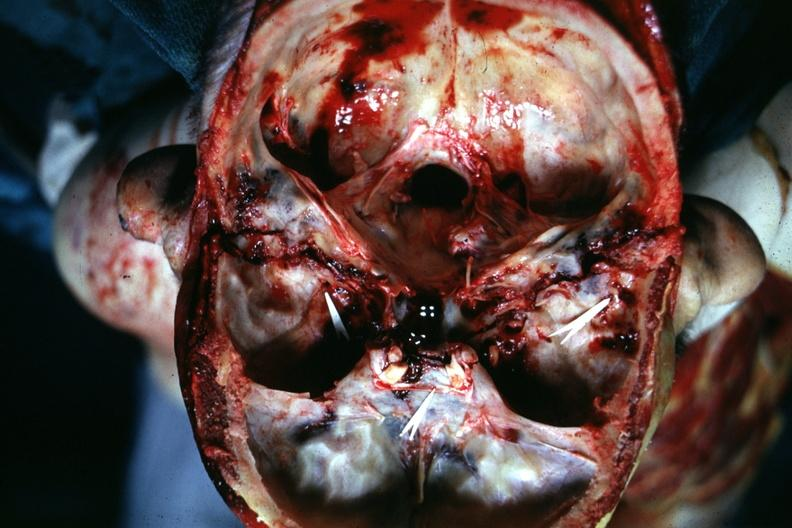what is present?
Answer the question using a single word or phrase. Bone 